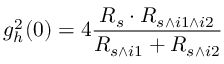Convert formula to latex. <formula><loc_0><loc_0><loc_500><loc_500>g _ { h } ^ { 2 } ( 0 ) = 4 \frac { R _ { s } \cdot R _ { s \wedge i 1 \wedge i 2 } } { R _ { s \wedge i 1 } + R _ { s \wedge i 2 } }</formula> 